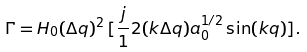Convert formula to latex. <formula><loc_0><loc_0><loc_500><loc_500>\Gamma = H _ { 0 } ( \Delta q ) ^ { 2 } \, [ \frac { j } { 1 } 2 ( k \Delta q ) a _ { 0 } ^ { 1 / 2 } \sin ( k q ) ] .</formula> 